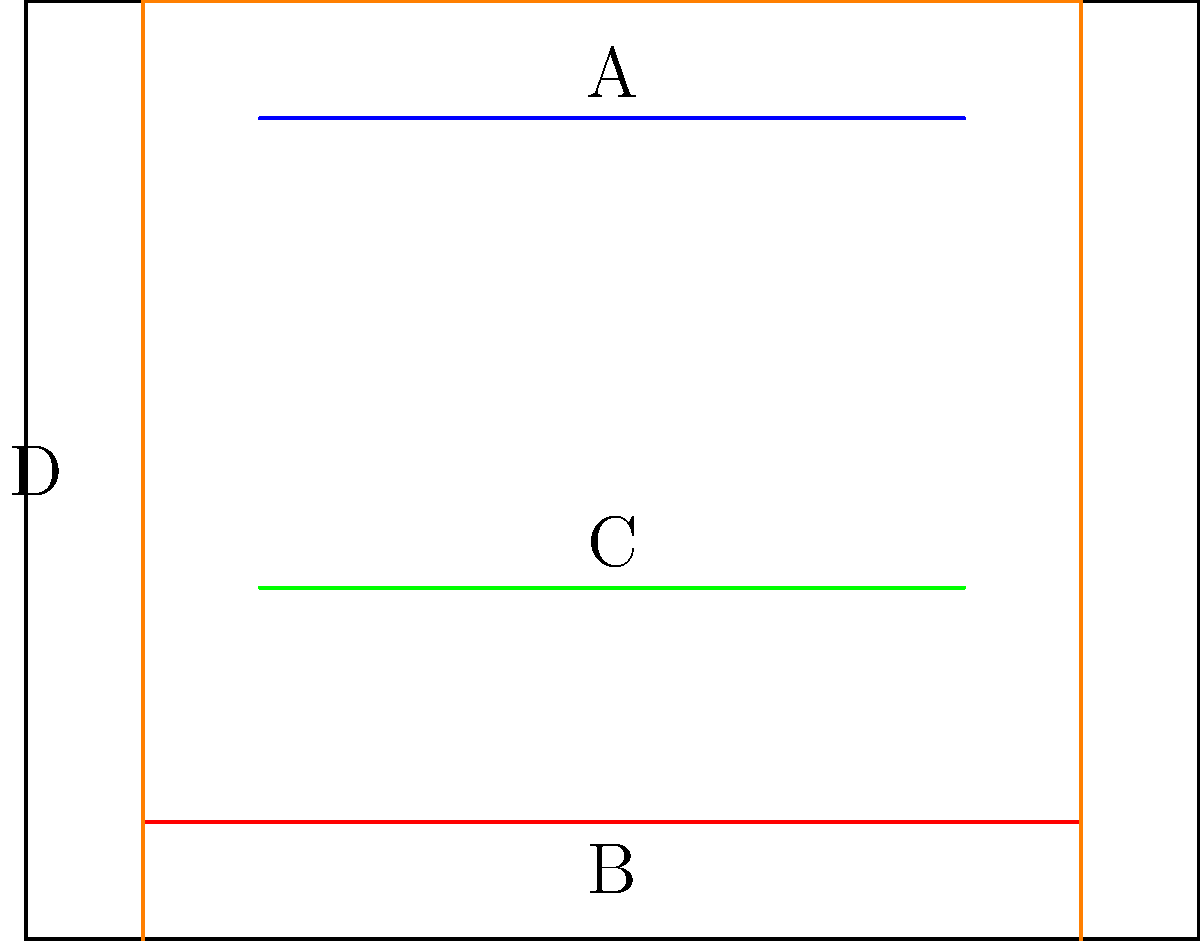As a science journalist interviewing a history professor, you're discussing Gutenberg's printing press. The diagram shows four key components of the press. Which sequence correctly represents the assembly order from bottom to top? To answer this question, we need to understand the basic structure and function of Gutenberg's printing press:

1. The frame (D) forms the base and structure of the press. It needs to be in place first to support all other components.

2. The type (B) is placed at the bottom of the press. This is where the movable type pieces are arranged to form the text to be printed.

3. The plate (C) goes above the type. This is the flat surface that presses down onto the paper and type to create the print.

4. The lever (A) is at the top of the press. It's used to apply pressure, pushing the plate down onto the paper and type.

Therefore, the correct assembly order from bottom to top is:

D (frame) → B (type) → C (plate) → A (lever)

This order reflects the logical construction of the press and its operational sequence.
Answer: D-B-C-A 